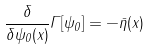<formula> <loc_0><loc_0><loc_500><loc_500>\frac { \delta } { \delta \psi _ { 0 } ( x ) } \Gamma [ \psi _ { 0 } ] = - \bar { \eta } ( x )</formula> 